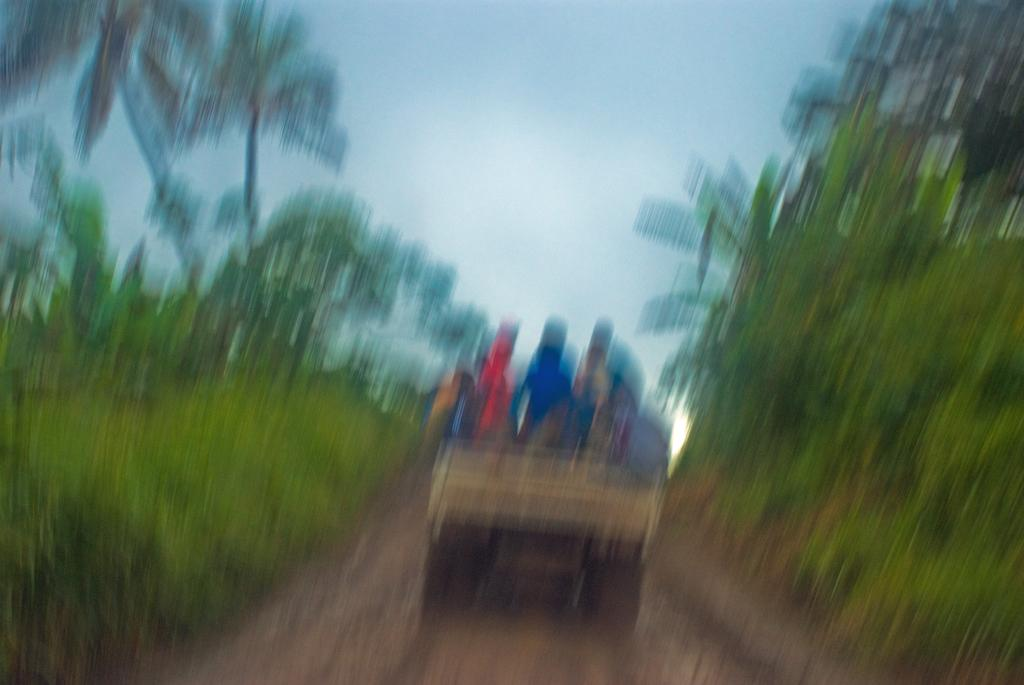What is the overall quality of the image? The image is blurry. What can be seen in the image despite the blurriness? There is a vehicle in the image. Who or what is on the vehicle? There are people on the vehicle. What type of environment surrounds the vehicle? There is greenery on either side of the vehicle. What is visible at the top of the image? The sky is visible at the top of the image. What type of cart is being pushed against the wall in the image? There is no cart or wall present in the image; it features a blurry image of a vehicle with people on it and greenery on either side. 